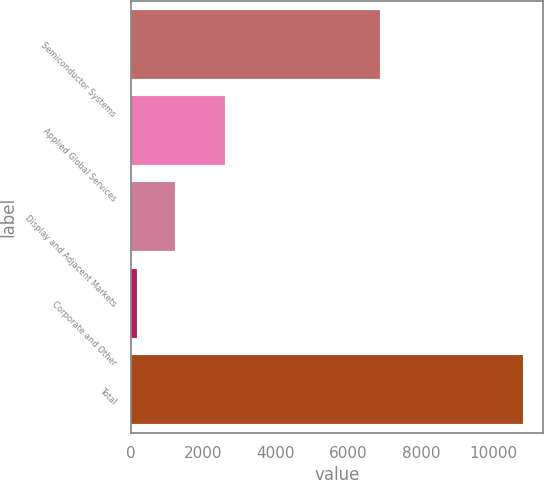Convert chart to OTSL. <chart><loc_0><loc_0><loc_500><loc_500><bar_chart><fcel>Semiconductor Systems<fcel>Applied Global Services<fcel>Display and Adjacent Markets<fcel>Corporate and Other<fcel>Total<nl><fcel>6873<fcel>2589<fcel>1223.8<fcel>157<fcel>10825<nl></chart> 